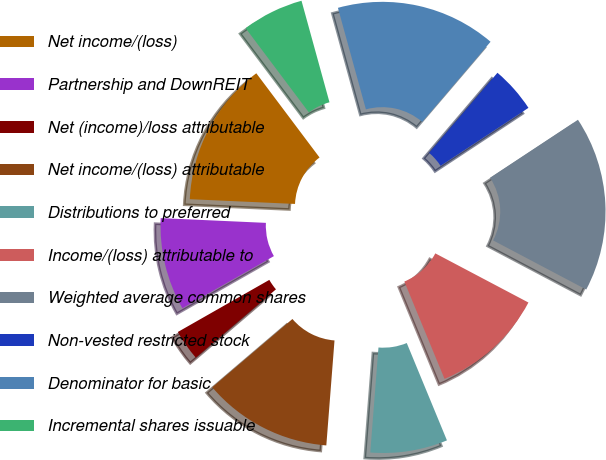<chart> <loc_0><loc_0><loc_500><loc_500><pie_chart><fcel>Net income/(loss)<fcel>Partnership and DownREIT<fcel>Net (income)/loss attributable<fcel>Net income/(loss) attributable<fcel>Distributions to preferred<fcel>Income/(loss) attributable to<fcel>Weighted average common shares<fcel>Non-vested restricted stock<fcel>Denominator for basic<fcel>Incremental shares issuable<nl><fcel>14.03%<fcel>8.96%<fcel>2.99%<fcel>12.53%<fcel>7.47%<fcel>11.04%<fcel>17.01%<fcel>4.48%<fcel>15.52%<fcel>5.97%<nl></chart> 